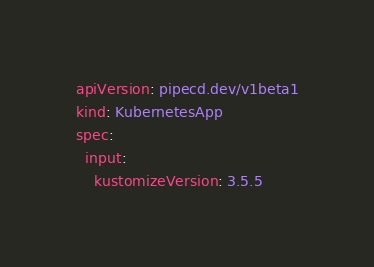<code> <loc_0><loc_0><loc_500><loc_500><_YAML_>apiVersion: pipecd.dev/v1beta1
kind: KubernetesApp
spec:
  input:
    kustomizeVersion: 3.5.5
</code> 